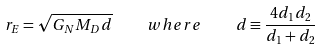<formula> <loc_0><loc_0><loc_500><loc_500>r _ { E } = \sqrt { G _ { N } M _ { D } d } \quad w h e r e \quad d \equiv \frac { 4 d _ { 1 } d _ { 2 } } { d _ { 1 } + d _ { 2 } }</formula> 